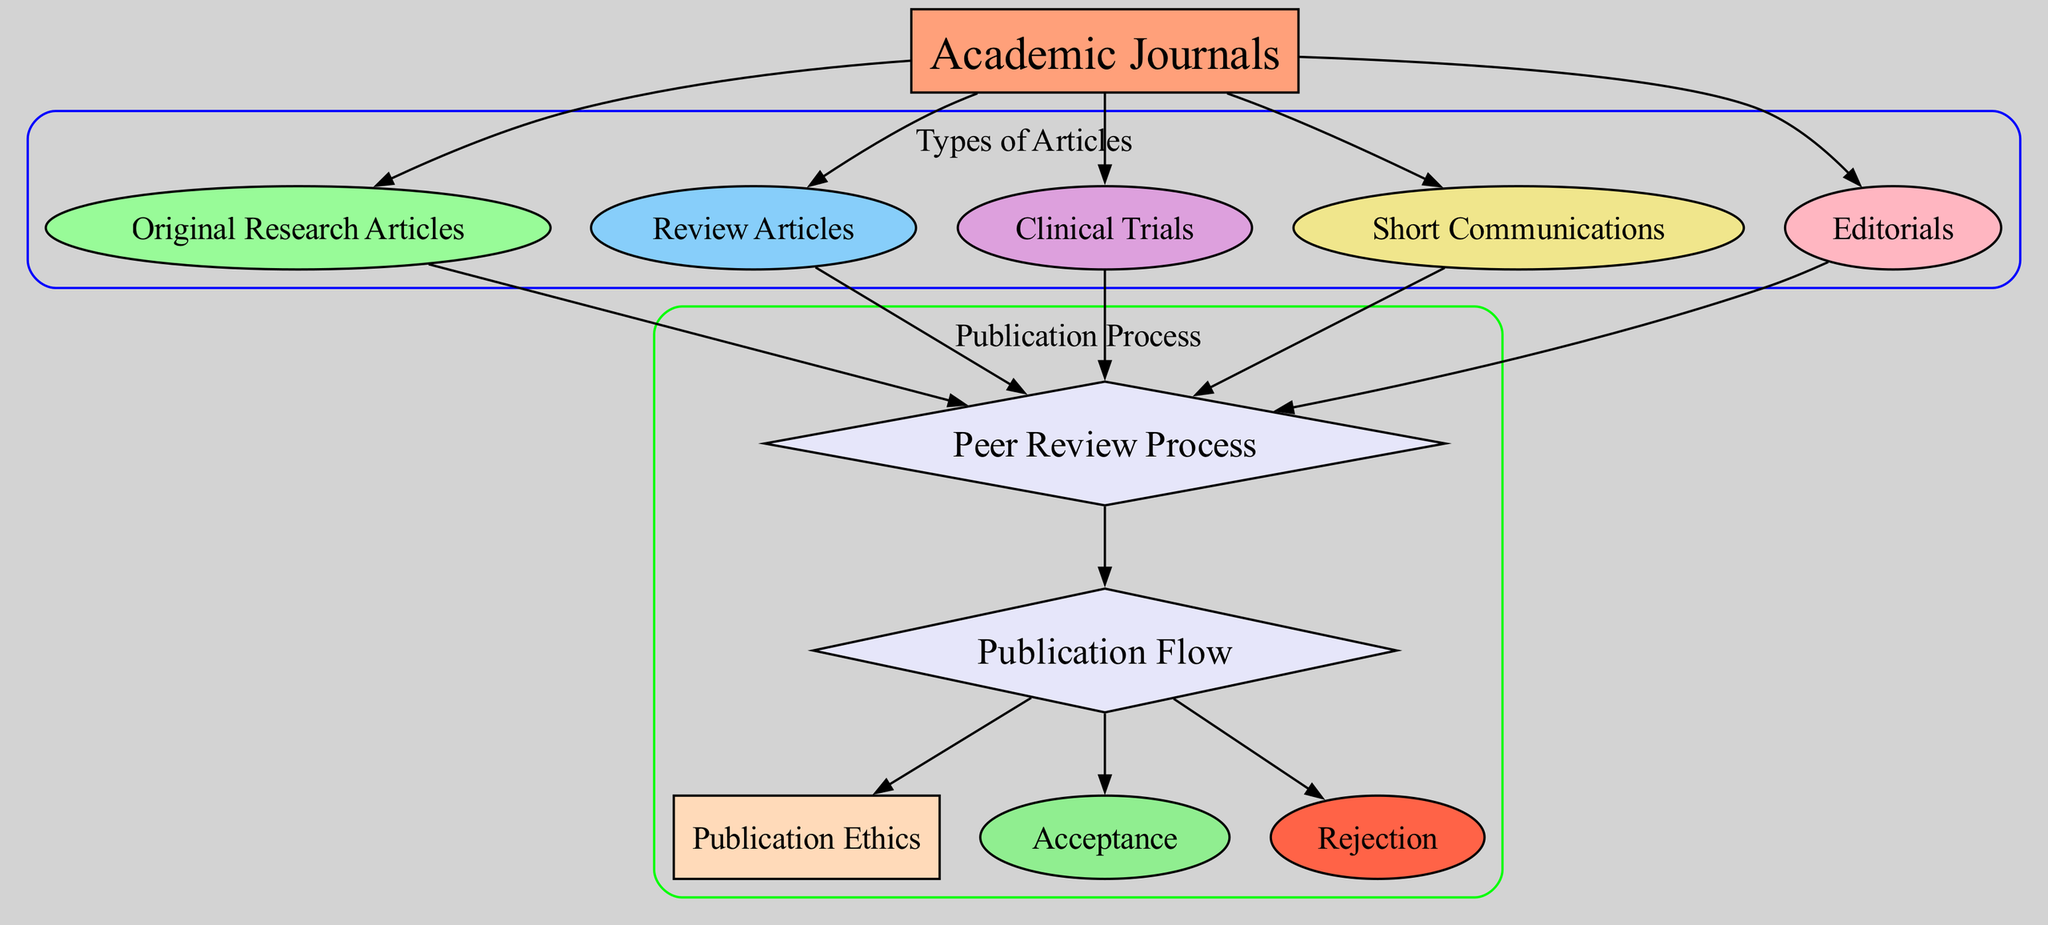What article types are illustrated in the diagram? The diagram lists five types of articles associated with academic journals: Original Research Articles, Review Articles, Clinical Trials, Short Communications, and Editorials. These nodes lead directly from the Academic Journals node, confirming these specific article types.
Answer: Original Research Articles, Review Articles, Clinical Trials, Short Communications, Editorials How many edges are there in total? The diagram contains a total of 13 edges, which connect various nodes to indicate relationships, such as the peer review process leading to acceptance, rejection, and publication ethics. By counting all the connections, we confirm there are 13 edges in total.
Answer: 13 Which node directs to Acceptance? The Acceptance node is connected to the Publication Flow node; from the diagrams’ edges, it is evident that the flow consists of nodes leading to outcomes like Acceptance (J) and Rejection (K).
Answer: Publication Flow What are the types of articles that undergo peer review? The types of articles that are associated with the peer review process, indicated by connections to the Peer Review Process node, involve Original Research Articles, Review Articles, Clinical Trials, Short Communications, and Editorials. Each of these article types directs to the Peer Review Process, indicating they undergo review.
Answer: Original Research Articles, Review Articles, Clinical Trials, Short Communications, Editorials How does the Publication Flow node connect with other nodes? The Publication Flow node is connected to three other nodes: Acceptance, Rejection, and Publication Ethics. The edges indicate that the Publication Flow encapsulates processes leading to either acceptance or rejection of articles and adheres to Publication Ethics guidelines thereafter.
Answer: Acceptance, Rejection, Publication Ethics Which article type is not part of the peer review process? The Editorials node is the article type that does not directly connect to the Peer Review Process node, highlighting that while most articles undergo peer review, Editorials are typically not subjected to this process.
Answer: Editorials What is the output of the Publication Flow node? The Publication Flow node can lead to three distinct outputs: Acceptance, Rejection, and Publication Ethics. This indicates that after peer review, an article could either be accepted or rejected, while also adhering to ethical standards surrounding publication.
Answer: Acceptance, Rejection, Publication Ethics Is there any article type classified without peer review? Yes, Editorials are classified in the diagram as being separate from the peer review process, indicating that they are not subject to the same review protocols as the other article types listed.
Answer: Editorials 